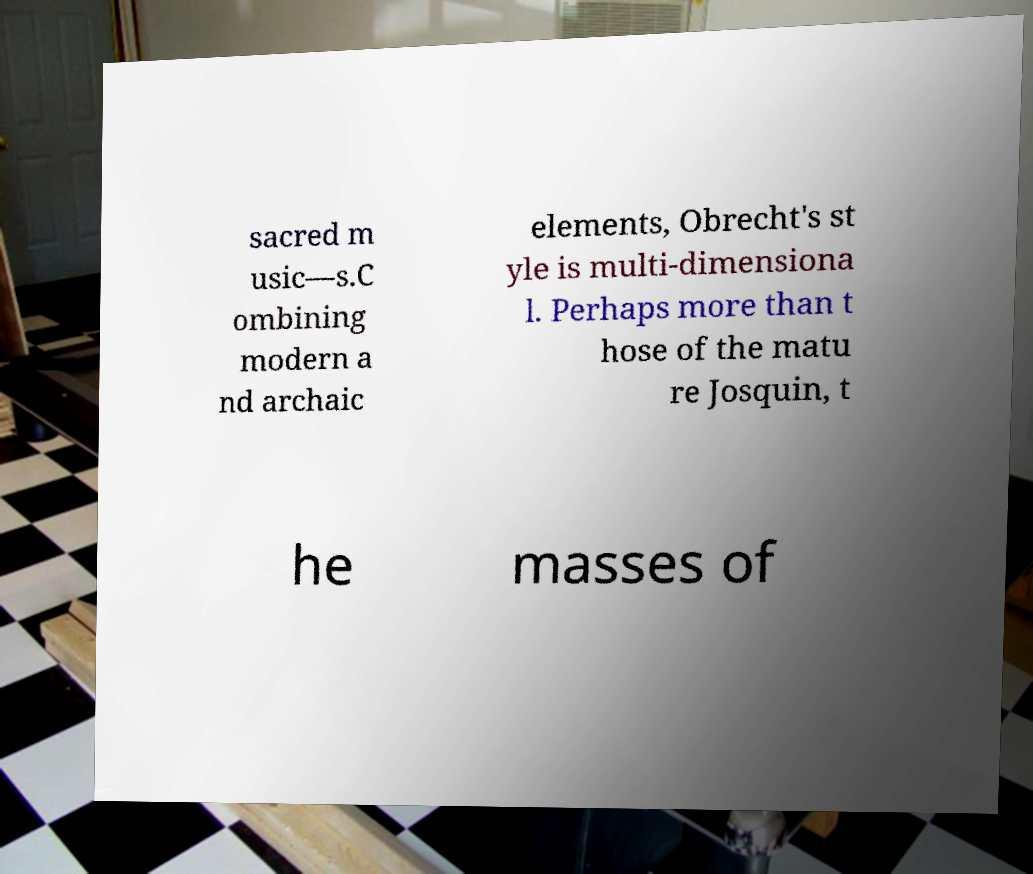What messages or text are displayed in this image? I need them in a readable, typed format. sacred m usic—s.C ombining modern a nd archaic elements, Obrecht's st yle is multi-dimensiona l. Perhaps more than t hose of the matu re Josquin, t he masses of 